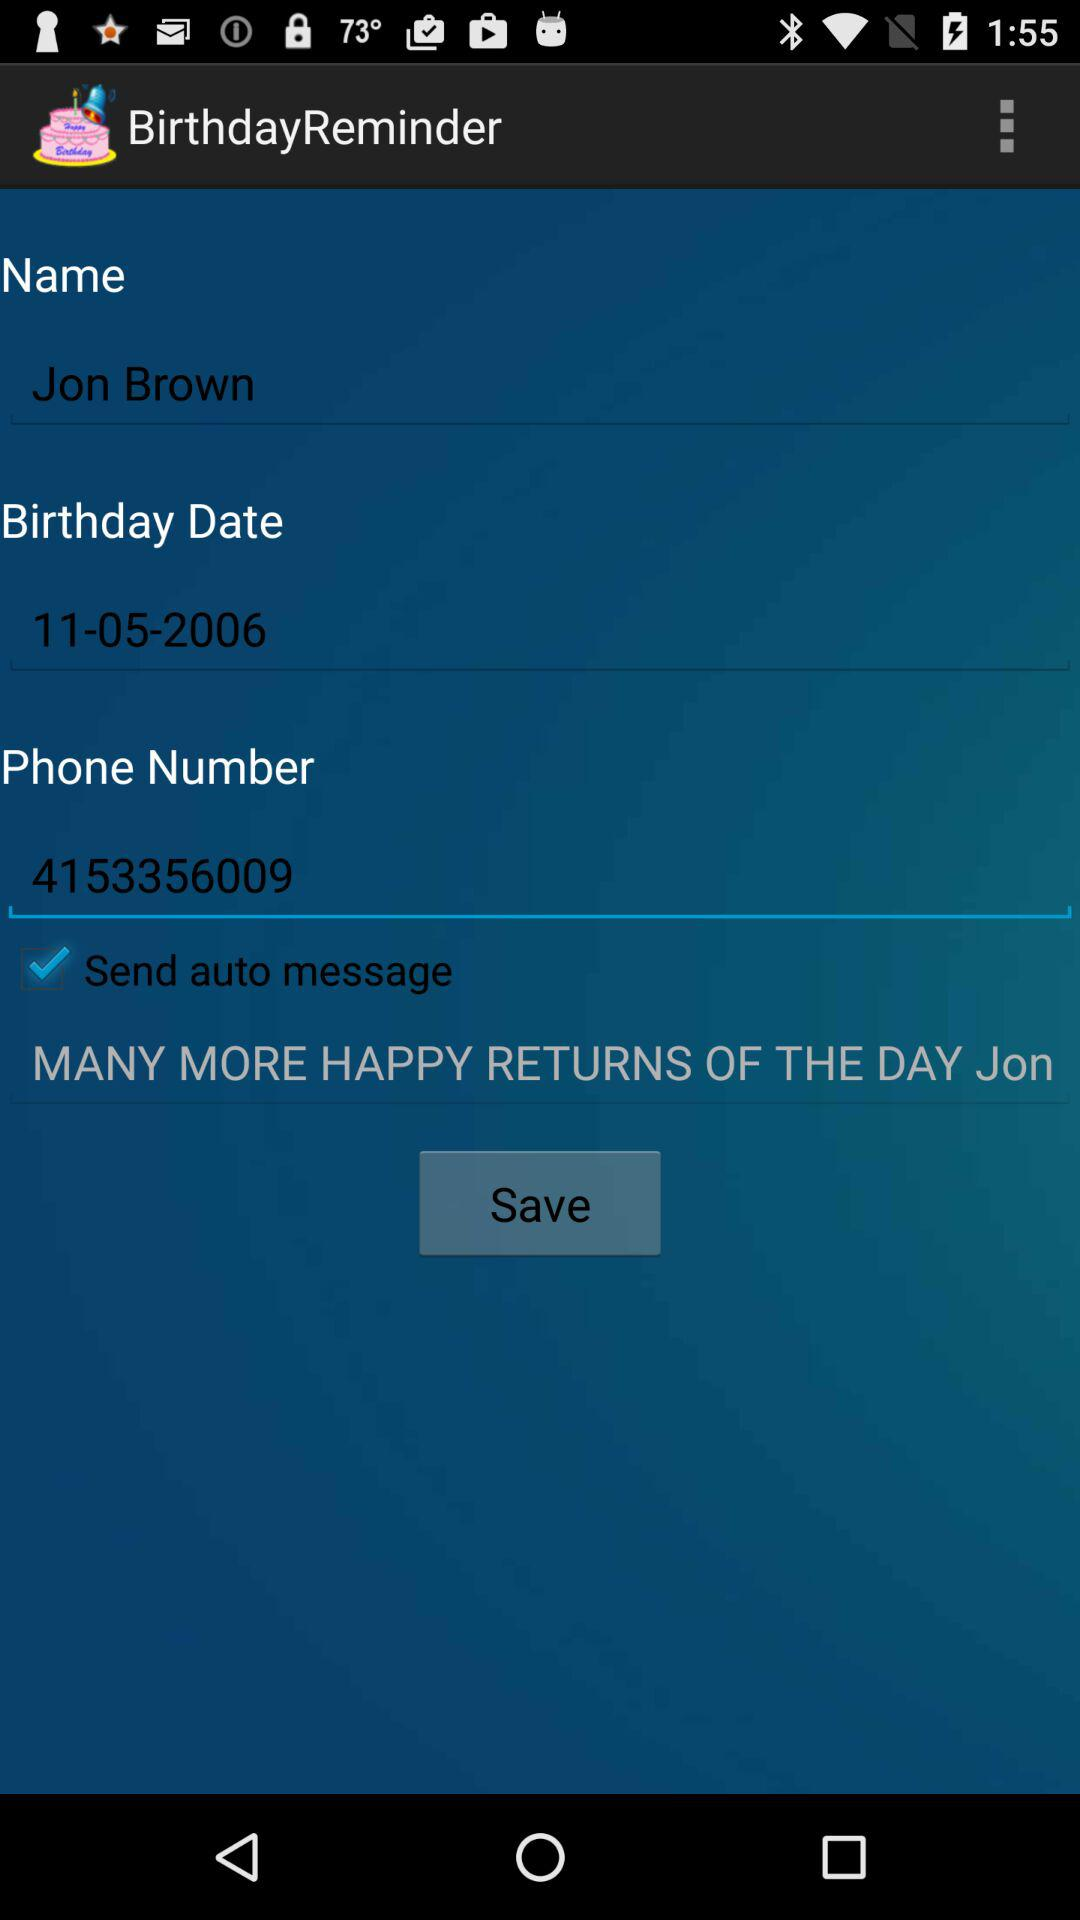What's the phone number? The phone number is 4153356009. 